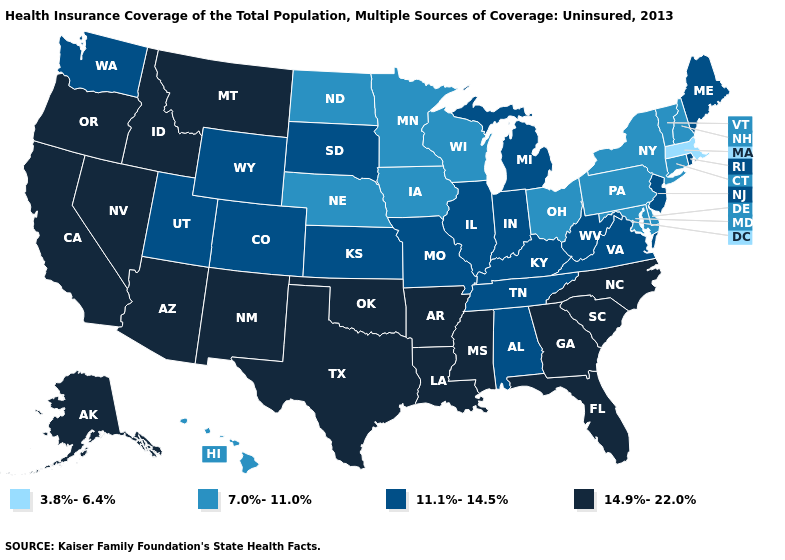What is the value of Arizona?
Quick response, please. 14.9%-22.0%. What is the lowest value in states that border New Mexico?
Answer briefly. 11.1%-14.5%. Does South Dakota have the lowest value in the USA?
Write a very short answer. No. Name the states that have a value in the range 11.1%-14.5%?
Keep it brief. Alabama, Colorado, Illinois, Indiana, Kansas, Kentucky, Maine, Michigan, Missouri, New Jersey, Rhode Island, South Dakota, Tennessee, Utah, Virginia, Washington, West Virginia, Wyoming. Which states have the lowest value in the West?
Quick response, please. Hawaii. What is the value of Colorado?
Give a very brief answer. 11.1%-14.5%. Name the states that have a value in the range 14.9%-22.0%?
Quick response, please. Alaska, Arizona, Arkansas, California, Florida, Georgia, Idaho, Louisiana, Mississippi, Montana, Nevada, New Mexico, North Carolina, Oklahoma, Oregon, South Carolina, Texas. Name the states that have a value in the range 3.8%-6.4%?
Short answer required. Massachusetts. Name the states that have a value in the range 11.1%-14.5%?
Quick response, please. Alabama, Colorado, Illinois, Indiana, Kansas, Kentucky, Maine, Michigan, Missouri, New Jersey, Rhode Island, South Dakota, Tennessee, Utah, Virginia, Washington, West Virginia, Wyoming. Name the states that have a value in the range 11.1%-14.5%?
Short answer required. Alabama, Colorado, Illinois, Indiana, Kansas, Kentucky, Maine, Michigan, Missouri, New Jersey, Rhode Island, South Dakota, Tennessee, Utah, Virginia, Washington, West Virginia, Wyoming. Does Massachusetts have the lowest value in the Northeast?
Write a very short answer. Yes. Name the states that have a value in the range 3.8%-6.4%?
Write a very short answer. Massachusetts. Name the states that have a value in the range 7.0%-11.0%?
Be succinct. Connecticut, Delaware, Hawaii, Iowa, Maryland, Minnesota, Nebraska, New Hampshire, New York, North Dakota, Ohio, Pennsylvania, Vermont, Wisconsin. Among the states that border Idaho , which have the highest value?
Answer briefly. Montana, Nevada, Oregon. What is the highest value in the USA?
Be succinct. 14.9%-22.0%. 